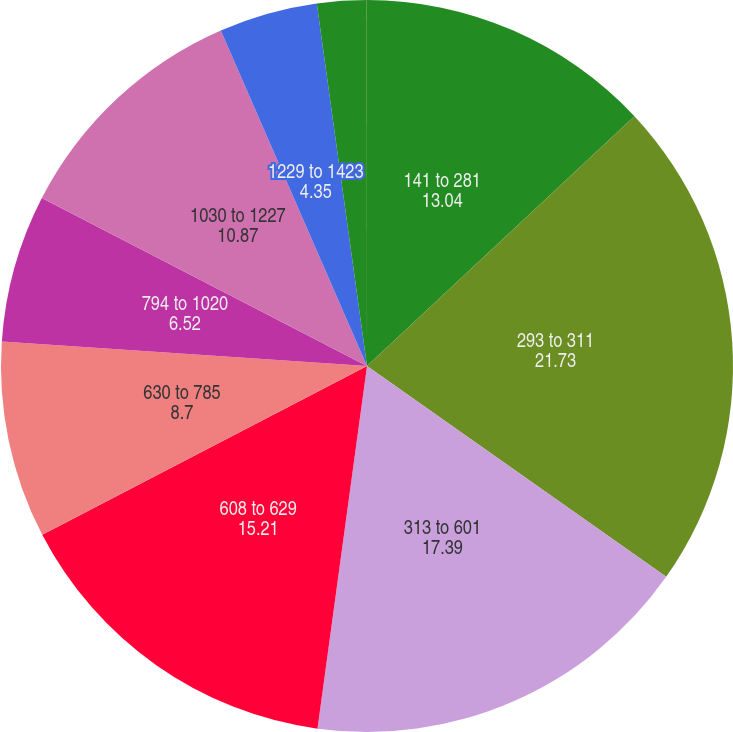Convert chart to OTSL. <chart><loc_0><loc_0><loc_500><loc_500><pie_chart><fcel>141 to 281<fcel>293 to 311<fcel>313 to 601<fcel>608 to 629<fcel>630 to 785<fcel>794 to 1020<fcel>1030 to 1227<fcel>1229 to 1423<fcel>1446 to 1446<fcel>1477 to 1477<nl><fcel>13.04%<fcel>21.73%<fcel>17.39%<fcel>15.21%<fcel>8.7%<fcel>6.52%<fcel>10.87%<fcel>4.35%<fcel>2.18%<fcel>0.01%<nl></chart> 